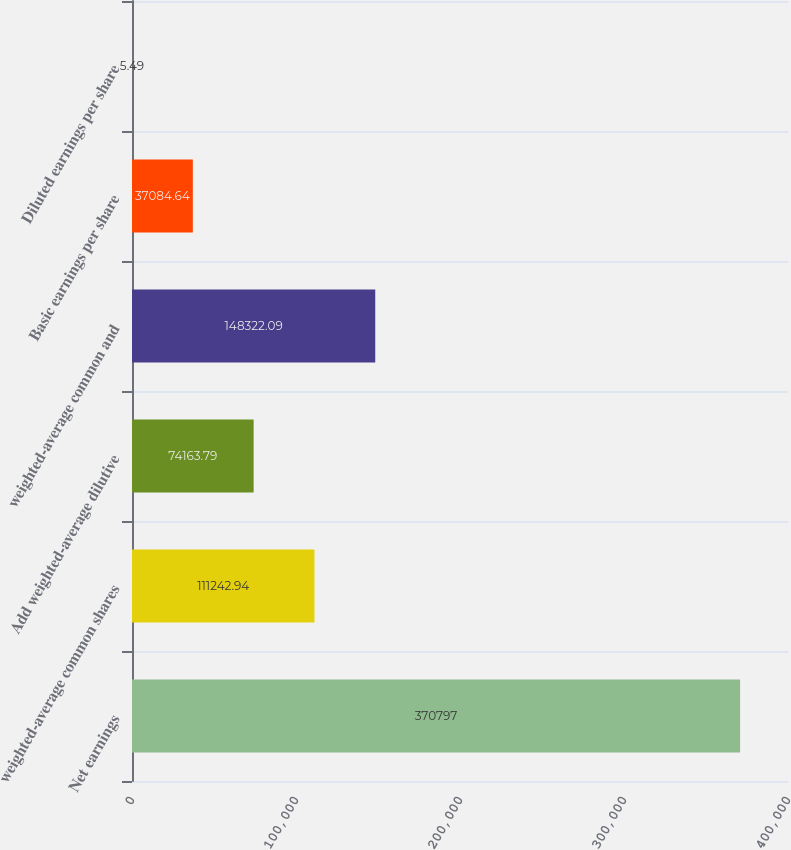<chart> <loc_0><loc_0><loc_500><loc_500><bar_chart><fcel>Net earnings<fcel>weighted-average common shares<fcel>Add weighted-average dilutive<fcel>weighted-average common and<fcel>Basic earnings per share<fcel>Diluted earnings per share<nl><fcel>370797<fcel>111243<fcel>74163.8<fcel>148322<fcel>37084.6<fcel>5.49<nl></chart> 